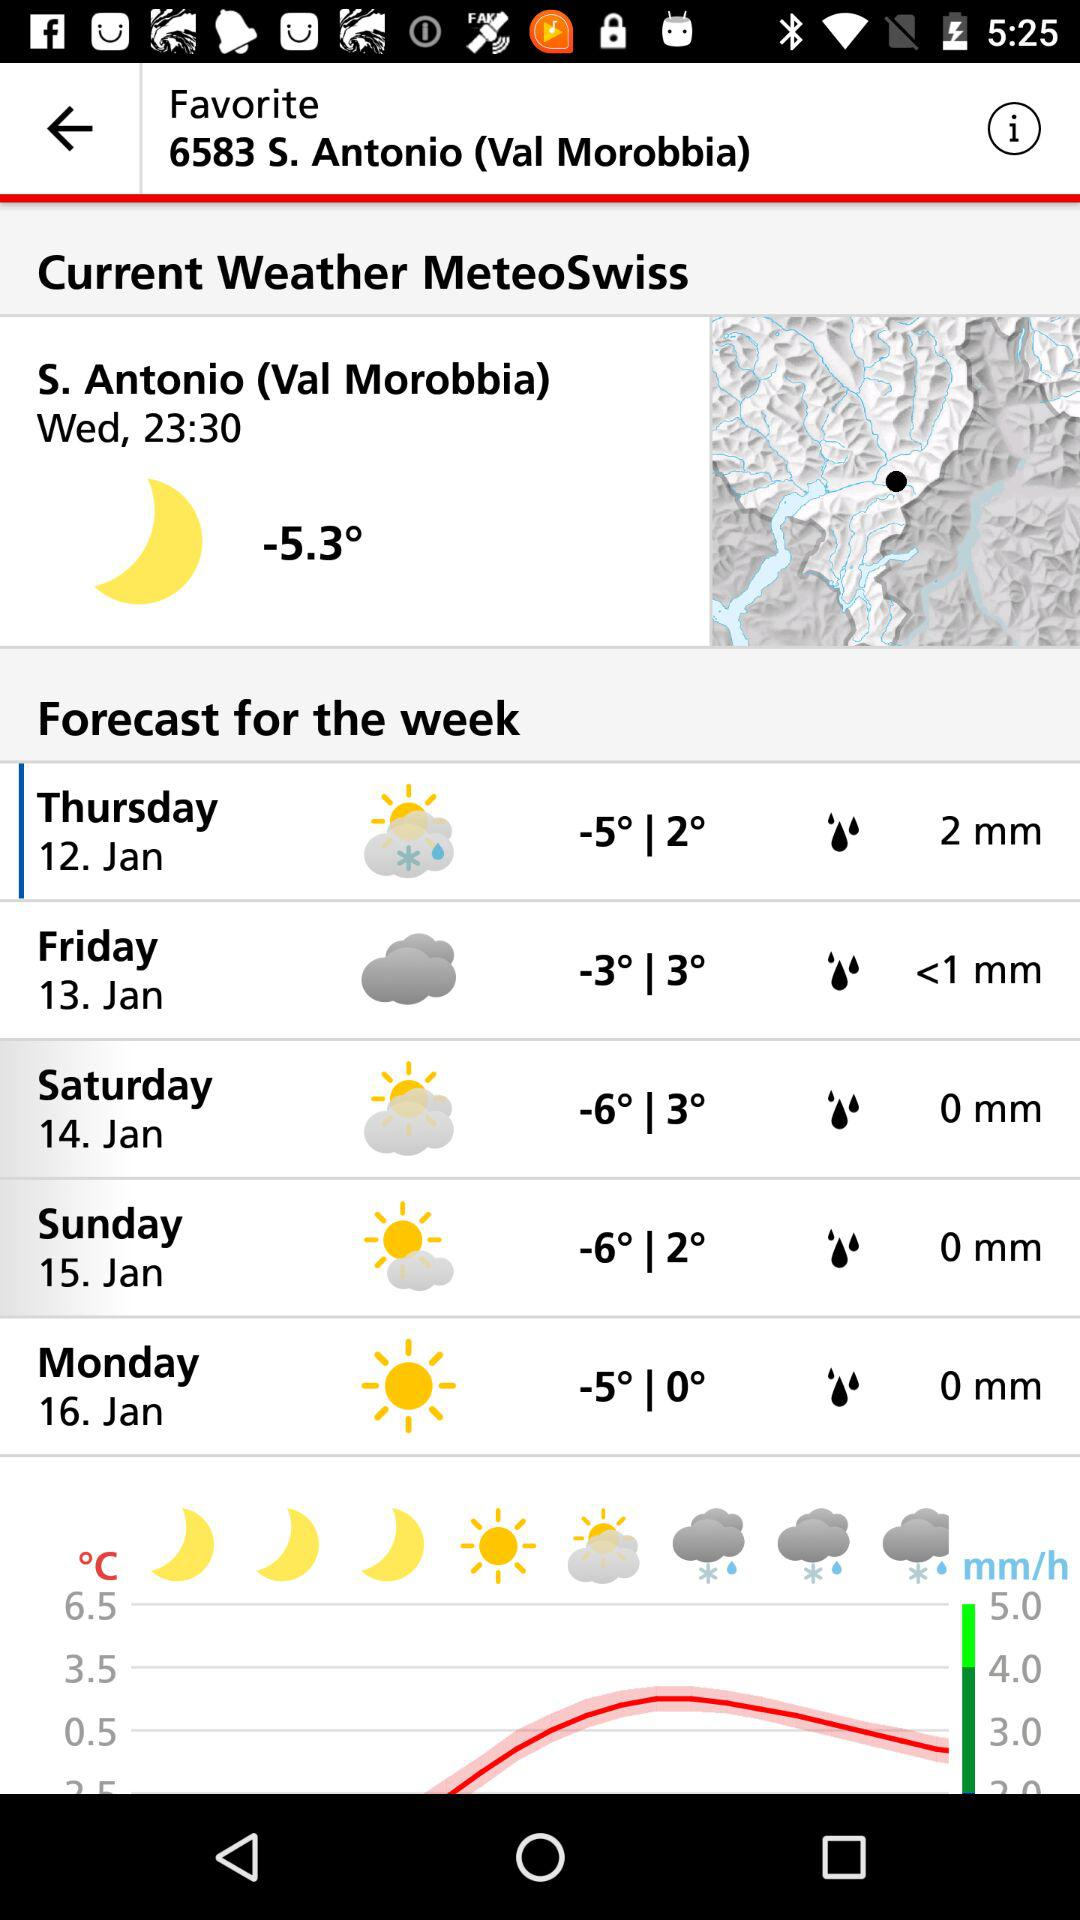What is the maximum temperature on Monday?
When the provided information is insufficient, respond with <no answer>. <no answer> 